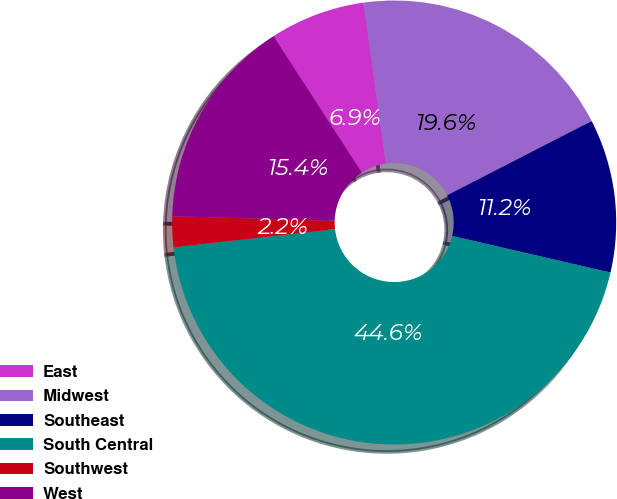Convert chart. <chart><loc_0><loc_0><loc_500><loc_500><pie_chart><fcel>East<fcel>Midwest<fcel>Southeast<fcel>South Central<fcel>Southwest<fcel>West<nl><fcel>6.94%<fcel>19.65%<fcel>11.17%<fcel>44.6%<fcel>2.23%<fcel>15.41%<nl></chart> 